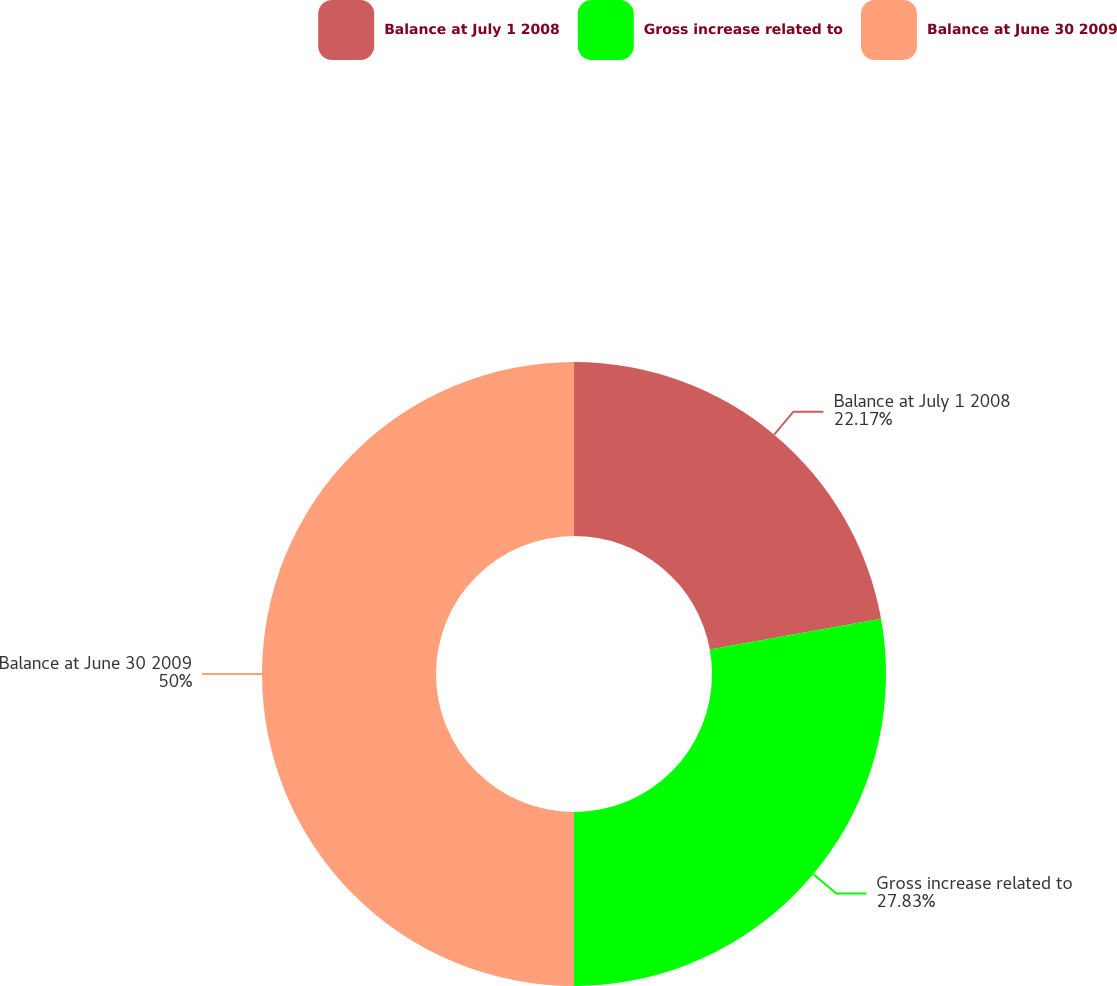Convert chart. <chart><loc_0><loc_0><loc_500><loc_500><pie_chart><fcel>Balance at July 1 2008<fcel>Gross increase related to<fcel>Balance at June 30 2009<nl><fcel>22.17%<fcel>27.83%<fcel>50.0%<nl></chart> 